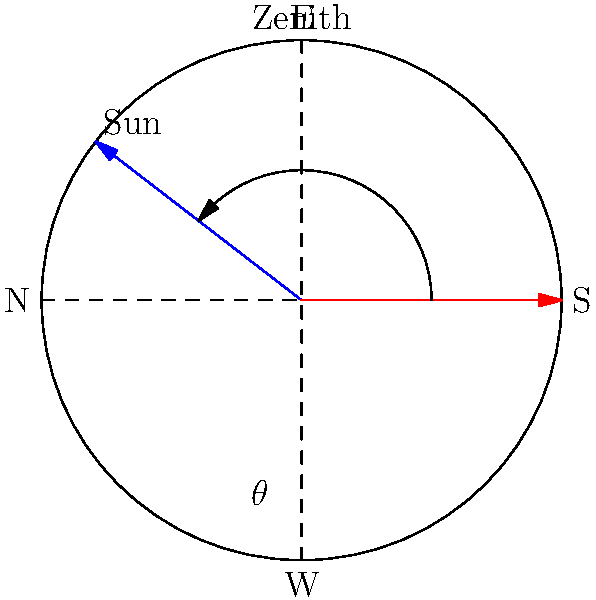Using the celestial sphere diagram for Rome, Italy (latitude 41.9°N), calculate the angle ($\theta$) between the zenith and the sun's position at solar noon during the summer solstice. Assume the Earth's axial tilt is 23.5°. To solve this problem, we'll follow these steps:

1) The angle we're looking for ($\theta$) is the complement of the sun's altitude at solar noon.

2) At the summer solstice, the sun is directly overhead at the Tropic of Cancer (23.5°N).

3) The difference between Rome's latitude and the Tropic of Cancer gives us the zenith distance:
   $41.9°N - 23.5°N = 18.4°$

4) This zenith distance (18.4°) is equal to our desired angle $\theta$.

5) We can verify this using the formula:
   $\theta = 90° - (90° - \text{latitude} + \text{declination})$
   $\theta = 90° - (90° - 41.9° + 23.5°)$
   $\theta = 90° - 71.6° = 18.4°$

Therefore, the angle between the zenith and the sun's position at solar noon during the summer solstice in Rome is 18.4°.
Answer: $18.4°$ 